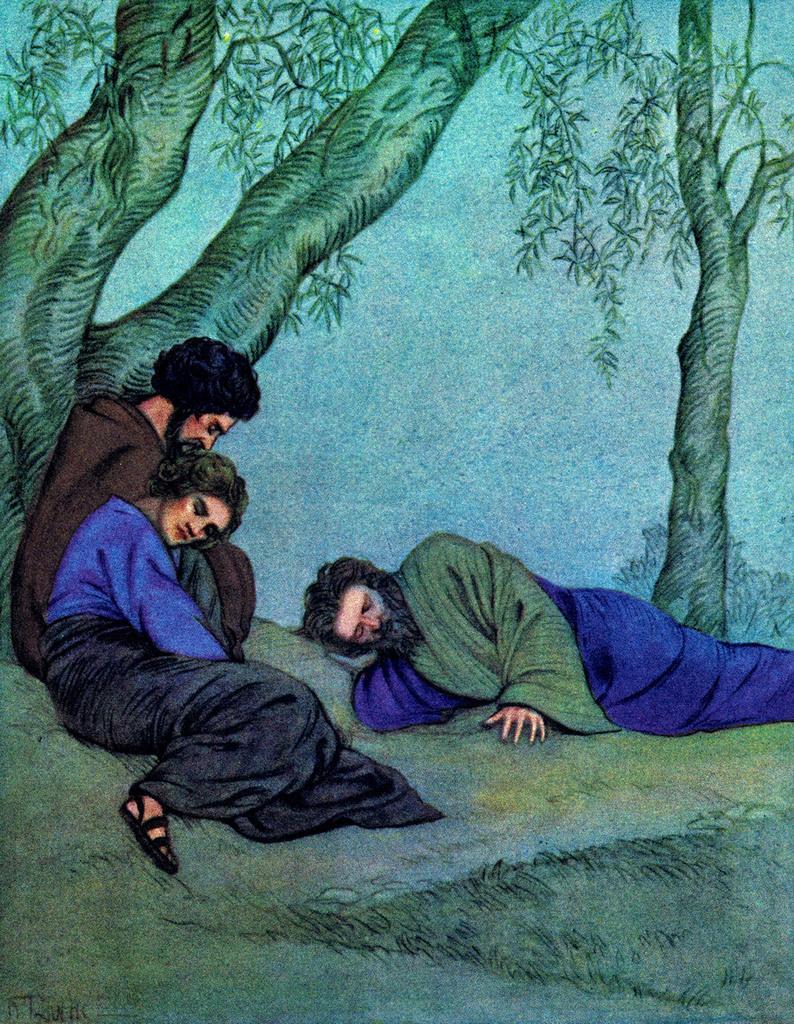In one or two sentences, can you explain what this image depicts? This is a painting. On the left side of the image we can see two people are sitting on the ground. In the middle of the image we can see a man is lying on the ground. In the background of the image we can see the trees, sky, grass. 